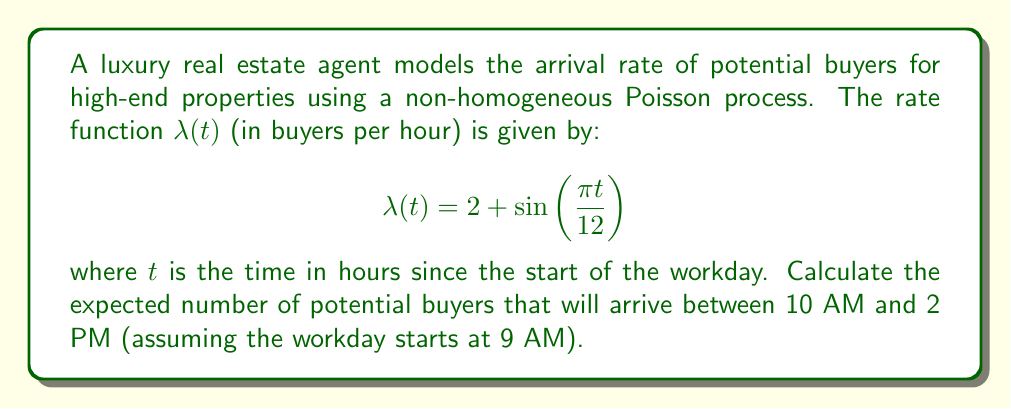Show me your answer to this math problem. To solve this problem, we need to follow these steps:

1) For a non-homogeneous Poisson process, the expected number of arrivals in an interval $[a,b]$ is given by:

   $$E[N(b) - N(a)] = \int_a^b \lambda(t) dt$$

2) In our case, $a = 1$ (10 AM is 1 hour after 9 AM) and $b = 5$ (2 PM is 5 hours after 9 AM).

3) We need to calculate:

   $$\int_1^5 \left(2 + \sin\left(\frac{\pi t}{12}\right)\right) dt$$

4) Let's break this into two parts:

   $$\int_1^5 2 dt + \int_1^5 \sin\left(\frac{\pi t}{12}\right) dt$$

5) The first part is straightforward:

   $$\int_1^5 2 dt = 2t \bigg|_1^5 = 2(5-1) = 8$$

6) For the second part, we use the substitution $u = \frac{\pi t}{12}$:

   $$\int_1^5 \sin\left(\frac{\pi t}{12}\right) dt = \frac{12}{\pi} \int_{\pi/12}^{5\pi/12} \sin(u) du$$

7) Evaluating this:

   $$\frac{12}{\pi} \left[-\cos(u)\right]_{\pi/12}^{5\pi/12} = \frac{12}{\pi} \left[-\cos\left(\frac{5\pi}{12}\right) + \cos\left(\frac{\pi}{12}\right)\right]$$

8) Adding the results from steps 5 and 7:

   $$8 + \frac{12}{\pi} \left[-\cos\left(\frac{5\pi}{12}\right) + \cos\left(\frac{\pi}{12}\right)\right]$$

This is the expected number of potential buyers arriving between 10 AM and 2 PM.
Answer: $8 + \frac{12}{\pi} \left[-\cos\left(\frac{5\pi}{12}\right) + \cos\left(\frac{\pi}{12}\right)\right]$ 